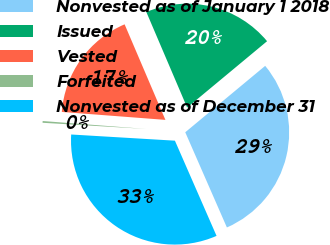Convert chart. <chart><loc_0><loc_0><loc_500><loc_500><pie_chart><fcel>Nonvested as of January 1 2018<fcel>Issued<fcel>Vested<fcel>Forfeited<fcel>Nonvested as of December 31<nl><fcel>29.47%<fcel>20.39%<fcel>17.36%<fcel>0.27%<fcel>32.51%<nl></chart> 